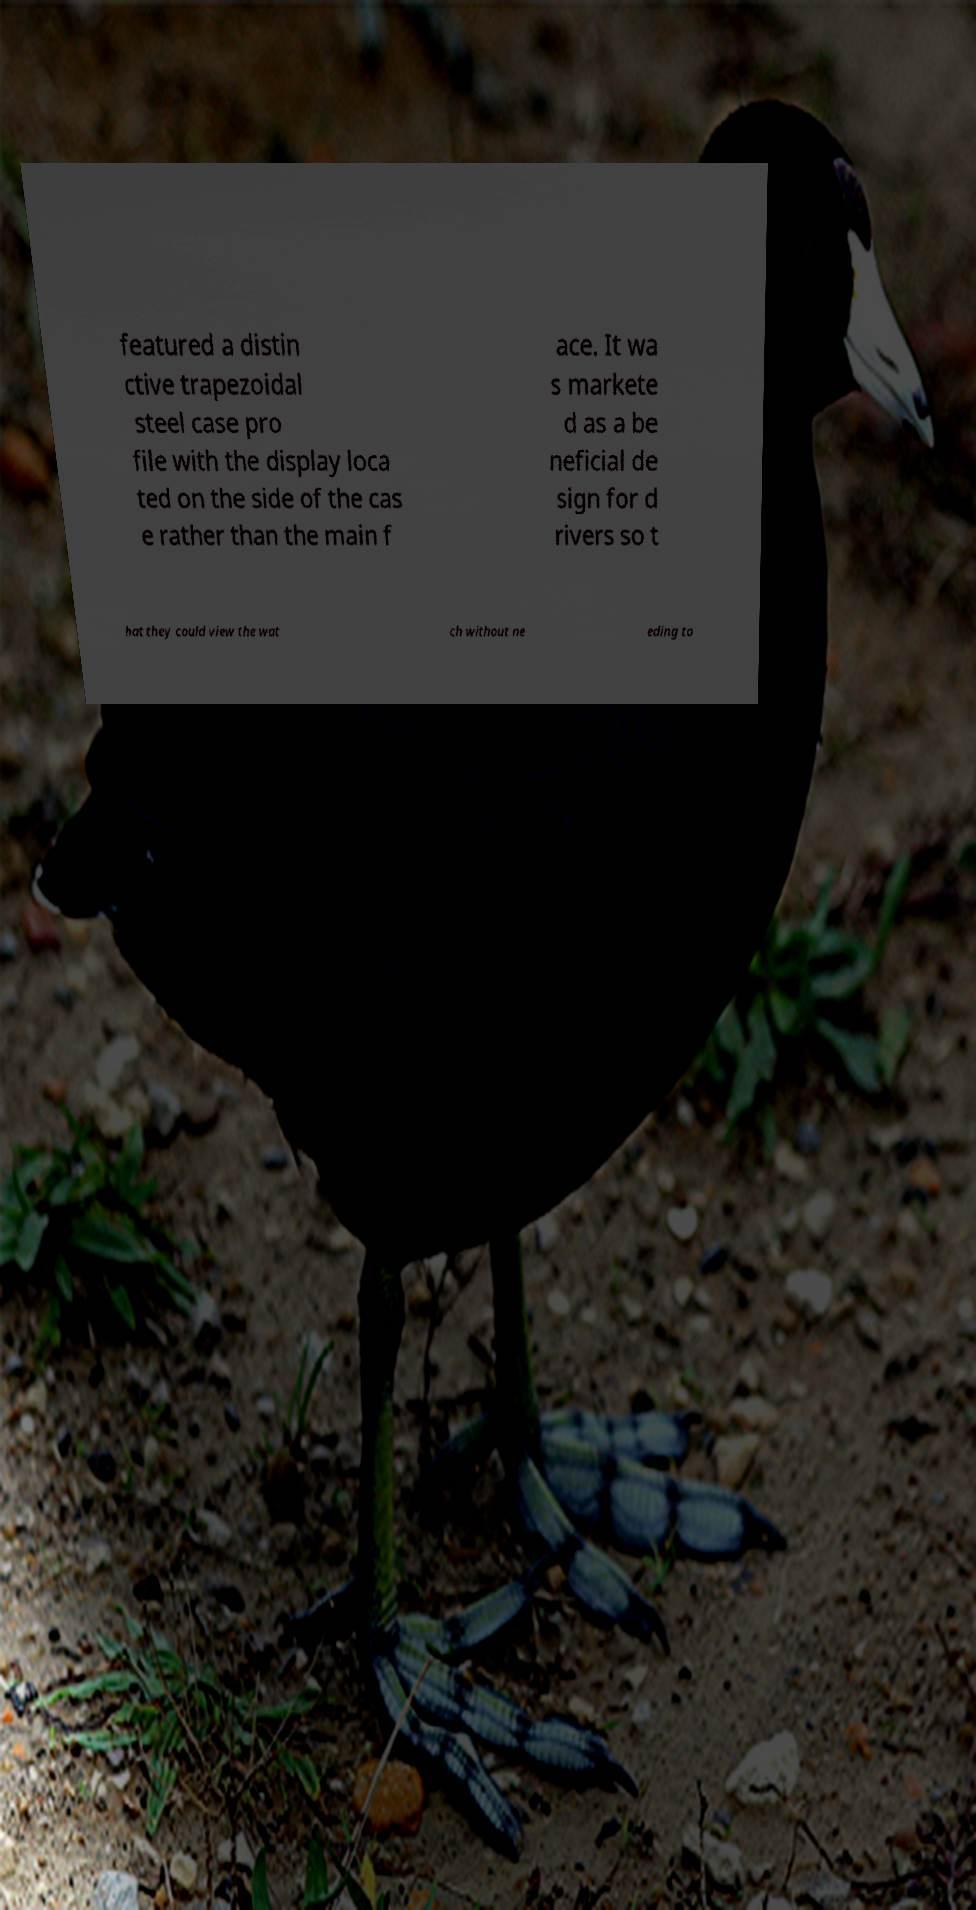Can you accurately transcribe the text from the provided image for me? featured a distin ctive trapezoidal steel case pro file with the display loca ted on the side of the cas e rather than the main f ace. It wa s markete d as a be neficial de sign for d rivers so t hat they could view the wat ch without ne eding to 